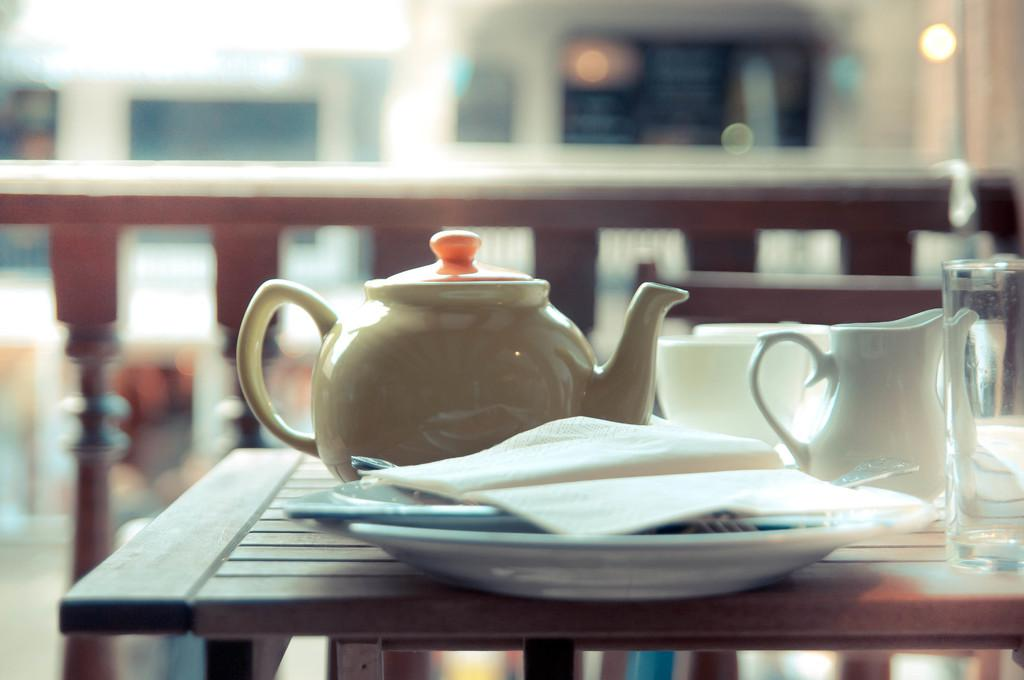What piece of furniture is present in the image? There is a table in the image. What is placed on the table? There is a tea kettle, tissues, plates, a cup, and a glass on the table. What might be used for drinking in the image? The cup and glass on the table might be used for drinking. What is visible in the background of the image? There is a railing in the background of the image. How many pets are visible in the image? There are no pets present in the image. What type of dirt can be seen on the table in the image? There is no dirt visible on the table in the image. 